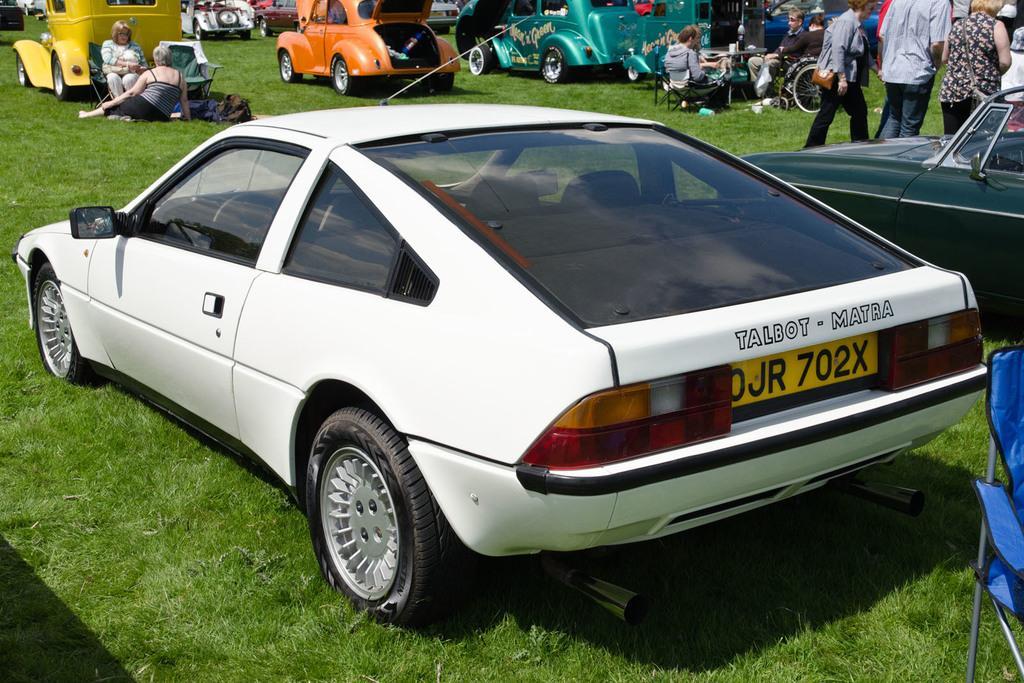Please provide a concise description of this image. In this image I can see grass ground and on it I can see number of vehicles. On the right side of this image I can see a blue colour chair. In the background I can see number of people where few are seating and few are standing. 